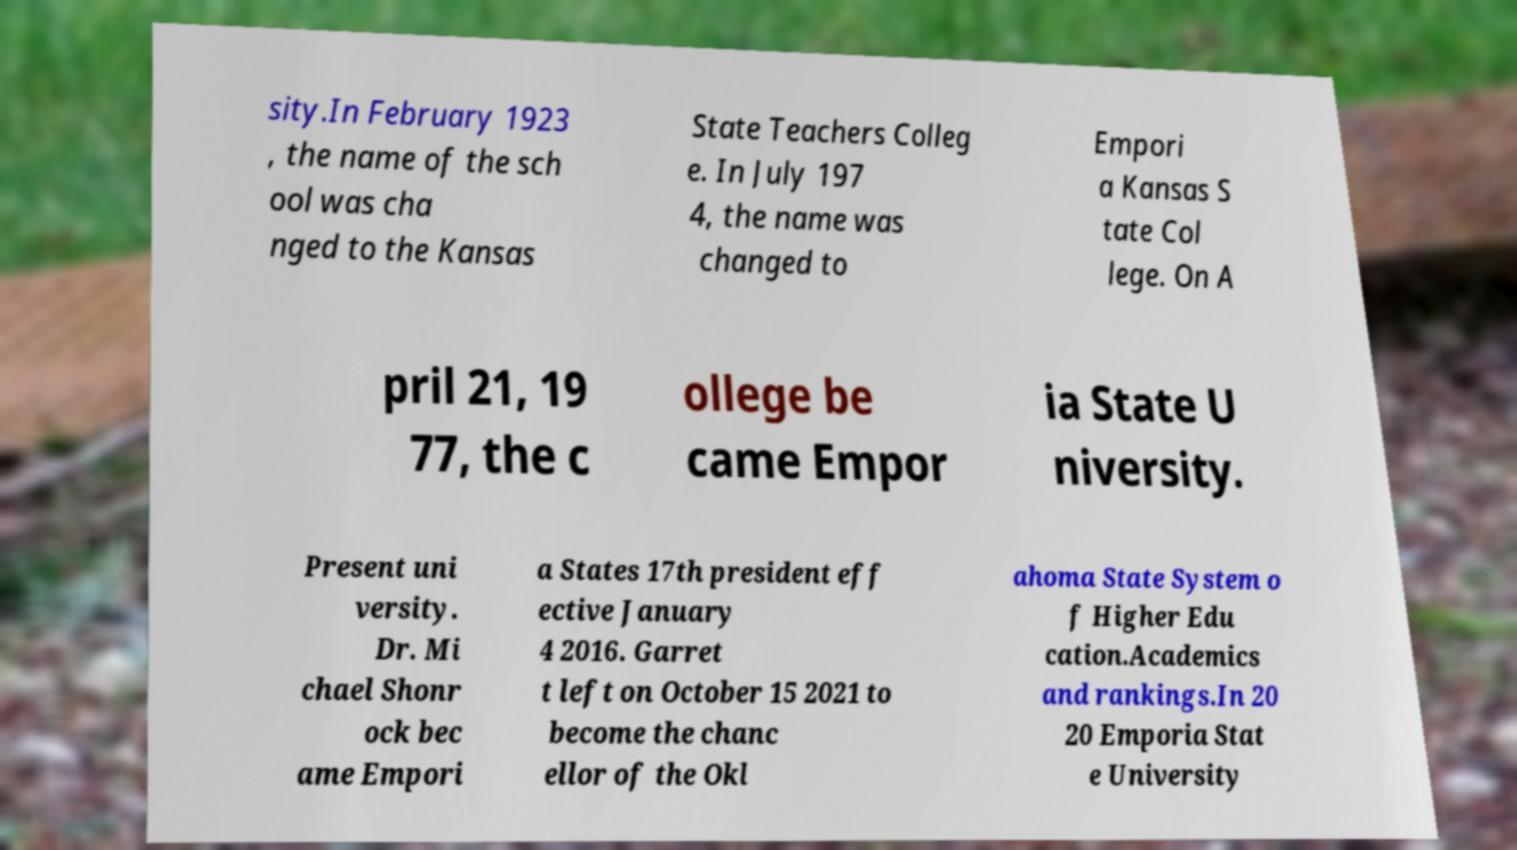Can you read and provide the text displayed in the image?This photo seems to have some interesting text. Can you extract and type it out for me? sity.In February 1923 , the name of the sch ool was cha nged to the Kansas State Teachers Colleg e. In July 197 4, the name was changed to Empori a Kansas S tate Col lege. On A pril 21, 19 77, the c ollege be came Empor ia State U niversity. Present uni versity. Dr. Mi chael Shonr ock bec ame Empori a States 17th president eff ective January 4 2016. Garret t left on October 15 2021 to become the chanc ellor of the Okl ahoma State System o f Higher Edu cation.Academics and rankings.In 20 20 Emporia Stat e University 